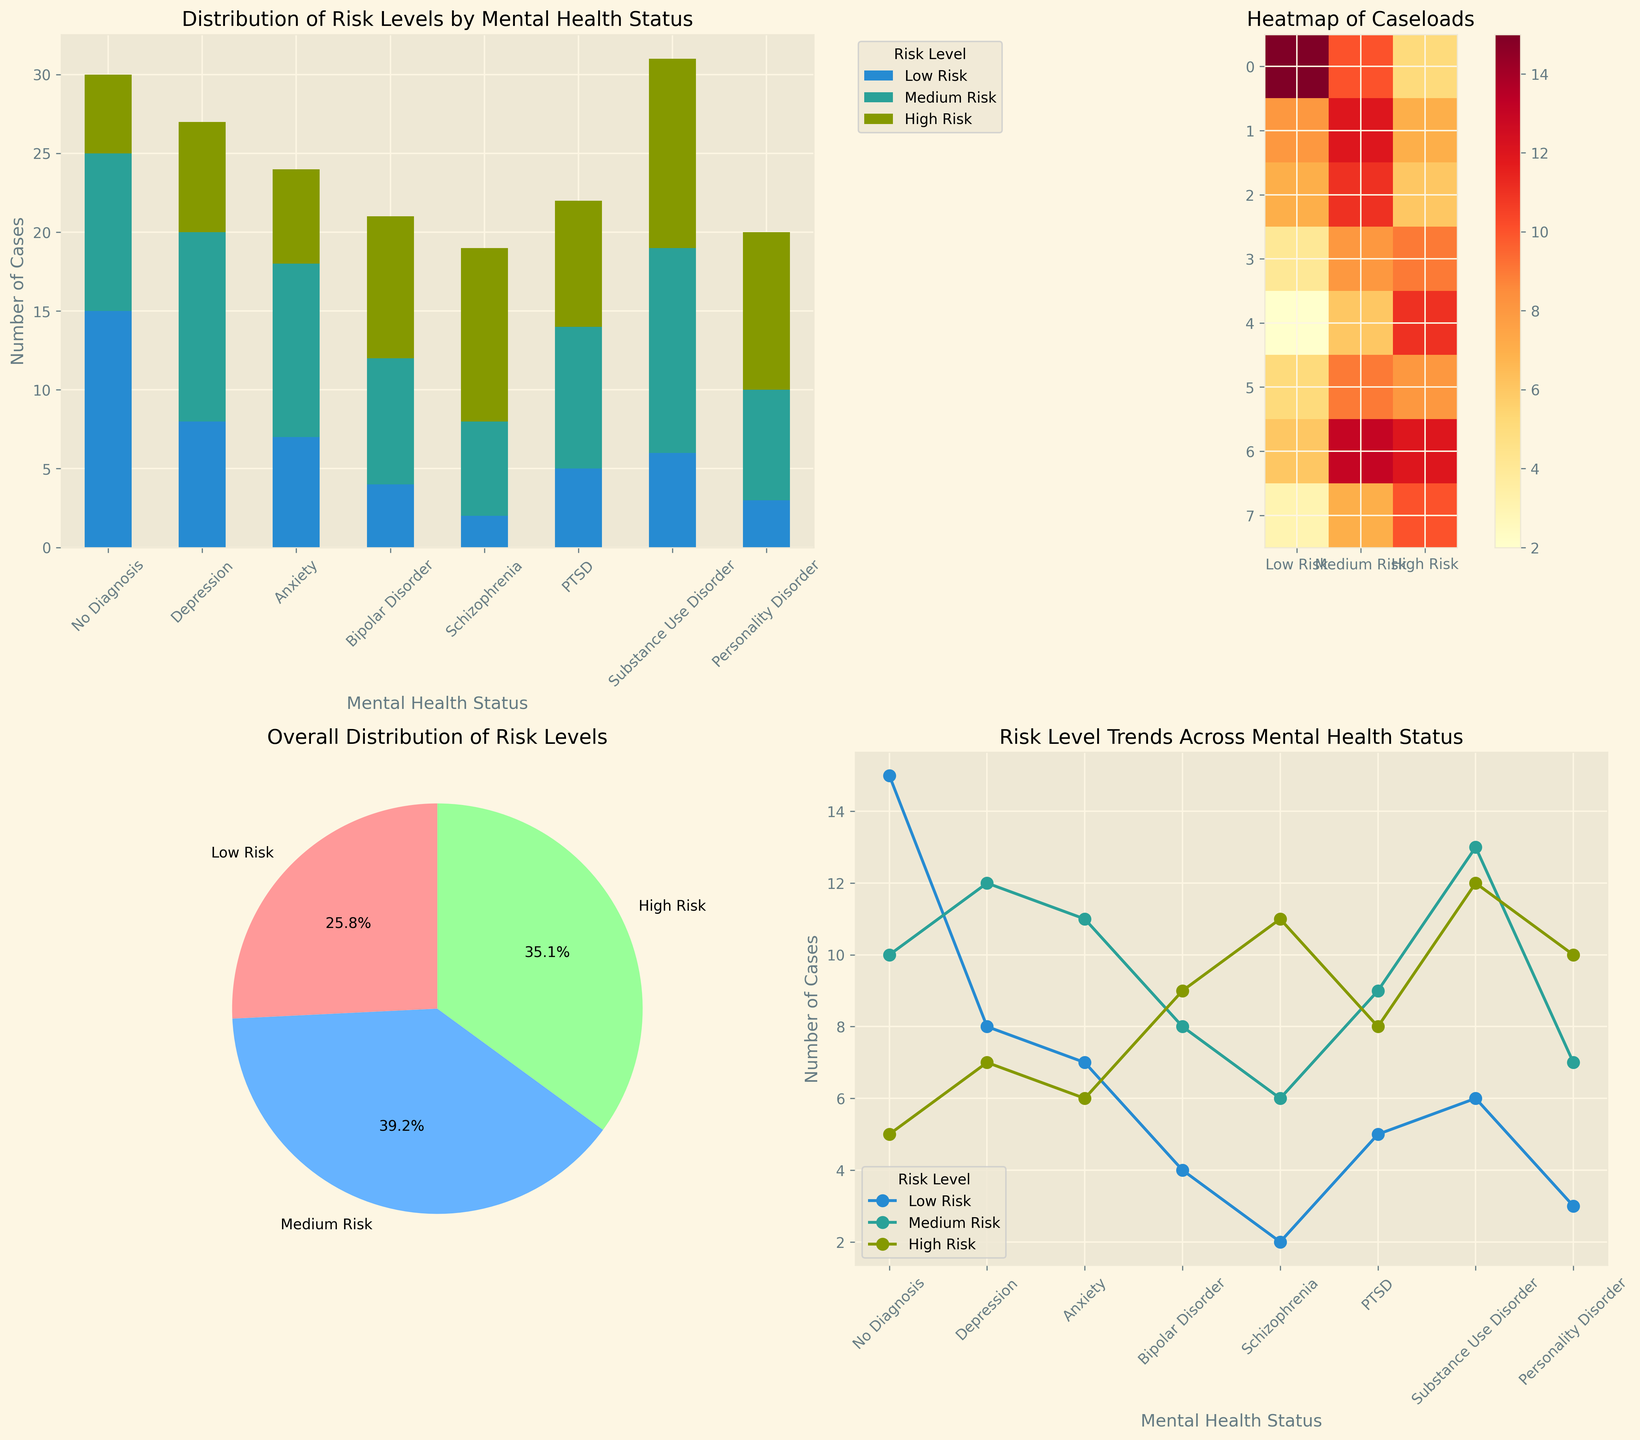What is the total number of cases for individuals with Schizophrenia in the high-risk category? Refer to the stacked bar chart or the heatmap. For Schizophrenia, the value in the high-risk category is 11.
Answer: 11 Which mental health condition has the highest number of low-risk cases? Check the stacked bar chart or the heatmap. No Diagnosis has the highest number in the low-risk category with 15 cases.
Answer: No Diagnosis Compare the total number of cases between Depression and PTSD across all risk levels. Which one is higher? Sum the counts for Depression (8 + 12 + 7) = 27 and PTSD (5 + 9 + 8) = 22 using the stacked bar chart, heatmap, or line plot. Depression has more cases.
Answer: Depression What percentage of total cases are medium-risk cases? Refer to the pie chart. Medium risk is 31.4% of the total cases.
Answer: 31.4% Which mental health condition has the greatest difference in the number of cases between low-risk and high-risk categories? The greatest difference can be observed from the bar chart or calculated from the data. For No Diagnosis: 15 (low) - 5 (high) = 10. This is the greatest observed difference.
Answer: No Diagnosis Which risk level has the largest representation overall, and its exact count? Check the pie chart or the sum of individual columns in the data. Medium Risk is the most represented with 76 cases.
Answer: Medium Risk, 76 What is the average number of cases across all risk levels for individuals with Anxiety? Sum the values for Anxiety (7 + 11 + 6) = 24, divide by 3. 24 / 3 = 8.
Answer: 8 What is the trend of the number of medium-risk cases across different mental health statuses? Refer to the line plot. The number of medium-risk cases generally increases except for a decrease for Personality Disorder.
Answer: Increasing, with a drop at Personality Disorder How many total cases involve individuals diagnosed with a Personality Disorder? Sum the counts for Personality Disorder from the bar chart or heatmap (3 + 7 + 10) = 20.
Answer: 20 What is the difference in high-risk cases between individuals with Bipolar Disorder and those with Substance Use Disorder? Check the high-risk values in the bar chart or heatmap: Bipolar Disorder (9), Substance Use Disorder (12). 12 - 9 = 3.
Answer: 3 